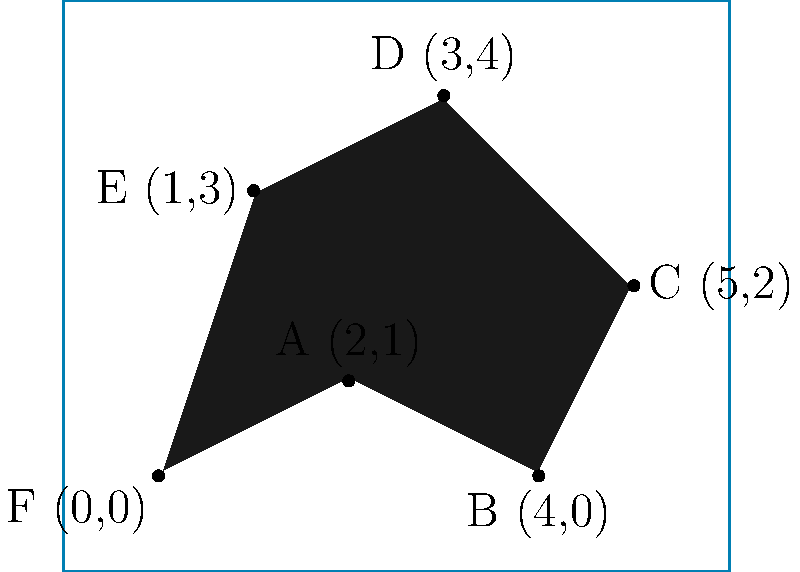An oil spill has occurred in the ocean, forming an irregular shape as shown in the image. To determine the extent of the environmental impact and plan containment efforts, you need to calculate the perimeter of the oil spill. Given the coordinates of the vertices (in kilometers) as shown, what is the total perimeter of the oil spill to the nearest 0.1 km? To calculate the perimeter, we need to find the distance between each pair of consecutive points and sum them up. We'll use the distance formula: $d = \sqrt{(x_2-x_1)^2 + (y_2-y_1)^2}$

1) Distance FA: $\sqrt{(2-0)^2 + (1-0)^2} = \sqrt{5} \approx 2.236$ km

2) Distance AB: $\sqrt{(4-2)^2 + (0-1)^2} = \sqrt{5} \approx 2.236$ km

3) Distance BC: $\sqrt{(5-4)^2 + (2-0)^2} = \sqrt{5} \approx 2.236$ km

4) Distance CD: $\sqrt{(3-5)^2 + (4-2)^2} = \sqrt{8} \approx 2.828$ km

5) Distance DE: $\sqrt{(1-3)^2 + (3-4)^2} = \sqrt{5} \approx 2.236$ km

6) Distance EF: $\sqrt{(0-1)^2 + (0-3)^2} = \sqrt{10} \approx 3.162$ km

Total perimeter = 2.236 + 2.236 + 2.236 + 2.828 + 2.236 + 3.162 = 14.934 km

Rounding to the nearest 0.1 km, we get 14.9 km.
Answer: 14.9 km 